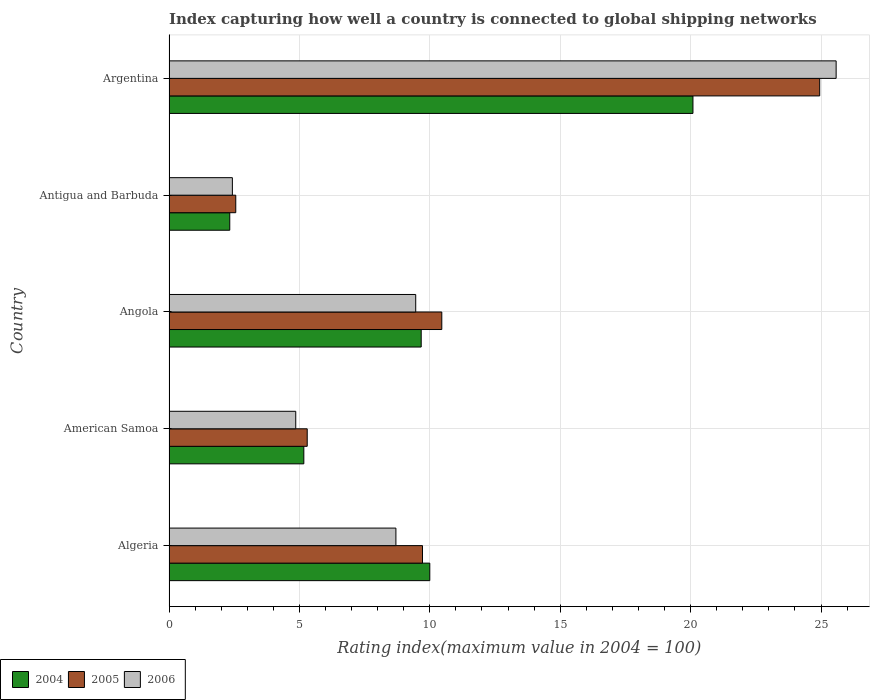How many groups of bars are there?
Provide a short and direct response. 5. How many bars are there on the 5th tick from the top?
Offer a very short reply. 3. How many bars are there on the 4th tick from the bottom?
Provide a short and direct response. 3. What is the label of the 2nd group of bars from the top?
Your answer should be compact. Antigua and Barbuda. What is the rating index in 2004 in Argentina?
Make the answer very short. 20.09. Across all countries, what is the maximum rating index in 2006?
Provide a short and direct response. 25.58. Across all countries, what is the minimum rating index in 2005?
Your answer should be very brief. 2.56. In which country was the rating index in 2005 minimum?
Your response must be concise. Antigua and Barbuda. What is the total rating index in 2006 in the graph?
Offer a terse response. 51.03. What is the difference between the rating index in 2005 in Algeria and that in Angola?
Provide a succinct answer. -0.74. What is the difference between the rating index in 2005 in Antigua and Barbuda and the rating index in 2006 in Algeria?
Offer a terse response. -6.14. What is the average rating index in 2004 per country?
Offer a very short reply. 9.45. What is the difference between the rating index in 2005 and rating index in 2004 in Antigua and Barbuda?
Make the answer very short. 0.23. What is the ratio of the rating index in 2004 in American Samoa to that in Argentina?
Keep it short and to the point. 0.26. Is the difference between the rating index in 2005 in American Samoa and Antigua and Barbuda greater than the difference between the rating index in 2004 in American Samoa and Antigua and Barbuda?
Give a very brief answer. No. What is the difference between the highest and the second highest rating index in 2006?
Give a very brief answer. 16.12. What is the difference between the highest and the lowest rating index in 2004?
Provide a short and direct response. 17.76. In how many countries, is the rating index in 2004 greater than the average rating index in 2004 taken over all countries?
Provide a short and direct response. 3. What does the 3rd bar from the top in American Samoa represents?
Your response must be concise. 2004. Are all the bars in the graph horizontal?
Give a very brief answer. Yes. How many countries are there in the graph?
Provide a short and direct response. 5. What is the difference between two consecutive major ticks on the X-axis?
Offer a very short reply. 5. Does the graph contain grids?
Your response must be concise. Yes. Where does the legend appear in the graph?
Provide a short and direct response. Bottom left. How many legend labels are there?
Give a very brief answer. 3. What is the title of the graph?
Your answer should be compact. Index capturing how well a country is connected to global shipping networks. What is the label or title of the X-axis?
Your answer should be compact. Rating index(maximum value in 2004 = 100). What is the label or title of the Y-axis?
Your answer should be very brief. Country. What is the Rating index(maximum value in 2004 = 100) of 2005 in Algeria?
Provide a short and direct response. 9.72. What is the Rating index(maximum value in 2004 = 100) in 2006 in Algeria?
Your answer should be compact. 8.7. What is the Rating index(maximum value in 2004 = 100) in 2004 in American Samoa?
Your answer should be very brief. 5.17. What is the Rating index(maximum value in 2004 = 100) of 2006 in American Samoa?
Keep it short and to the point. 4.86. What is the Rating index(maximum value in 2004 = 100) of 2004 in Angola?
Ensure brevity in your answer.  9.67. What is the Rating index(maximum value in 2004 = 100) of 2005 in Angola?
Your response must be concise. 10.46. What is the Rating index(maximum value in 2004 = 100) of 2006 in Angola?
Your response must be concise. 9.46. What is the Rating index(maximum value in 2004 = 100) of 2004 in Antigua and Barbuda?
Offer a terse response. 2.33. What is the Rating index(maximum value in 2004 = 100) of 2005 in Antigua and Barbuda?
Ensure brevity in your answer.  2.56. What is the Rating index(maximum value in 2004 = 100) of 2006 in Antigua and Barbuda?
Your response must be concise. 2.43. What is the Rating index(maximum value in 2004 = 100) in 2004 in Argentina?
Offer a very short reply. 20.09. What is the Rating index(maximum value in 2004 = 100) in 2005 in Argentina?
Give a very brief answer. 24.95. What is the Rating index(maximum value in 2004 = 100) of 2006 in Argentina?
Keep it short and to the point. 25.58. Across all countries, what is the maximum Rating index(maximum value in 2004 = 100) in 2004?
Offer a very short reply. 20.09. Across all countries, what is the maximum Rating index(maximum value in 2004 = 100) of 2005?
Provide a short and direct response. 24.95. Across all countries, what is the maximum Rating index(maximum value in 2004 = 100) of 2006?
Keep it short and to the point. 25.58. Across all countries, what is the minimum Rating index(maximum value in 2004 = 100) of 2004?
Your answer should be very brief. 2.33. Across all countries, what is the minimum Rating index(maximum value in 2004 = 100) in 2005?
Offer a terse response. 2.56. Across all countries, what is the minimum Rating index(maximum value in 2004 = 100) of 2006?
Your answer should be very brief. 2.43. What is the total Rating index(maximum value in 2004 = 100) in 2004 in the graph?
Your answer should be very brief. 47.26. What is the total Rating index(maximum value in 2004 = 100) in 2005 in the graph?
Offer a terse response. 52.99. What is the total Rating index(maximum value in 2004 = 100) in 2006 in the graph?
Offer a very short reply. 51.03. What is the difference between the Rating index(maximum value in 2004 = 100) in 2004 in Algeria and that in American Samoa?
Provide a succinct answer. 4.83. What is the difference between the Rating index(maximum value in 2004 = 100) in 2005 in Algeria and that in American Samoa?
Provide a succinct answer. 4.42. What is the difference between the Rating index(maximum value in 2004 = 100) of 2006 in Algeria and that in American Samoa?
Provide a short and direct response. 3.84. What is the difference between the Rating index(maximum value in 2004 = 100) of 2004 in Algeria and that in Angola?
Your answer should be very brief. 0.33. What is the difference between the Rating index(maximum value in 2004 = 100) in 2005 in Algeria and that in Angola?
Ensure brevity in your answer.  -0.74. What is the difference between the Rating index(maximum value in 2004 = 100) in 2006 in Algeria and that in Angola?
Keep it short and to the point. -0.76. What is the difference between the Rating index(maximum value in 2004 = 100) in 2004 in Algeria and that in Antigua and Barbuda?
Make the answer very short. 7.67. What is the difference between the Rating index(maximum value in 2004 = 100) of 2005 in Algeria and that in Antigua and Barbuda?
Make the answer very short. 7.16. What is the difference between the Rating index(maximum value in 2004 = 100) in 2006 in Algeria and that in Antigua and Barbuda?
Your response must be concise. 6.27. What is the difference between the Rating index(maximum value in 2004 = 100) in 2004 in Algeria and that in Argentina?
Give a very brief answer. -10.09. What is the difference between the Rating index(maximum value in 2004 = 100) of 2005 in Algeria and that in Argentina?
Make the answer very short. -15.23. What is the difference between the Rating index(maximum value in 2004 = 100) of 2006 in Algeria and that in Argentina?
Offer a very short reply. -16.88. What is the difference between the Rating index(maximum value in 2004 = 100) in 2004 in American Samoa and that in Angola?
Your answer should be very brief. -4.5. What is the difference between the Rating index(maximum value in 2004 = 100) in 2005 in American Samoa and that in Angola?
Your answer should be compact. -5.16. What is the difference between the Rating index(maximum value in 2004 = 100) in 2004 in American Samoa and that in Antigua and Barbuda?
Ensure brevity in your answer.  2.84. What is the difference between the Rating index(maximum value in 2004 = 100) of 2005 in American Samoa and that in Antigua and Barbuda?
Offer a very short reply. 2.74. What is the difference between the Rating index(maximum value in 2004 = 100) of 2006 in American Samoa and that in Antigua and Barbuda?
Ensure brevity in your answer.  2.43. What is the difference between the Rating index(maximum value in 2004 = 100) of 2004 in American Samoa and that in Argentina?
Make the answer very short. -14.92. What is the difference between the Rating index(maximum value in 2004 = 100) of 2005 in American Samoa and that in Argentina?
Give a very brief answer. -19.65. What is the difference between the Rating index(maximum value in 2004 = 100) in 2006 in American Samoa and that in Argentina?
Keep it short and to the point. -20.72. What is the difference between the Rating index(maximum value in 2004 = 100) in 2004 in Angola and that in Antigua and Barbuda?
Provide a succinct answer. 7.34. What is the difference between the Rating index(maximum value in 2004 = 100) in 2005 in Angola and that in Antigua and Barbuda?
Your response must be concise. 7.9. What is the difference between the Rating index(maximum value in 2004 = 100) in 2006 in Angola and that in Antigua and Barbuda?
Your answer should be compact. 7.03. What is the difference between the Rating index(maximum value in 2004 = 100) of 2004 in Angola and that in Argentina?
Your answer should be compact. -10.42. What is the difference between the Rating index(maximum value in 2004 = 100) in 2005 in Angola and that in Argentina?
Keep it short and to the point. -14.49. What is the difference between the Rating index(maximum value in 2004 = 100) in 2006 in Angola and that in Argentina?
Give a very brief answer. -16.12. What is the difference between the Rating index(maximum value in 2004 = 100) of 2004 in Antigua and Barbuda and that in Argentina?
Give a very brief answer. -17.76. What is the difference between the Rating index(maximum value in 2004 = 100) in 2005 in Antigua and Barbuda and that in Argentina?
Give a very brief answer. -22.39. What is the difference between the Rating index(maximum value in 2004 = 100) of 2006 in Antigua and Barbuda and that in Argentina?
Provide a succinct answer. -23.15. What is the difference between the Rating index(maximum value in 2004 = 100) of 2004 in Algeria and the Rating index(maximum value in 2004 = 100) of 2006 in American Samoa?
Make the answer very short. 5.14. What is the difference between the Rating index(maximum value in 2004 = 100) in 2005 in Algeria and the Rating index(maximum value in 2004 = 100) in 2006 in American Samoa?
Your answer should be compact. 4.86. What is the difference between the Rating index(maximum value in 2004 = 100) of 2004 in Algeria and the Rating index(maximum value in 2004 = 100) of 2005 in Angola?
Offer a very short reply. -0.46. What is the difference between the Rating index(maximum value in 2004 = 100) of 2004 in Algeria and the Rating index(maximum value in 2004 = 100) of 2006 in Angola?
Your response must be concise. 0.54. What is the difference between the Rating index(maximum value in 2004 = 100) of 2005 in Algeria and the Rating index(maximum value in 2004 = 100) of 2006 in Angola?
Your answer should be very brief. 0.26. What is the difference between the Rating index(maximum value in 2004 = 100) in 2004 in Algeria and the Rating index(maximum value in 2004 = 100) in 2005 in Antigua and Barbuda?
Provide a short and direct response. 7.44. What is the difference between the Rating index(maximum value in 2004 = 100) of 2004 in Algeria and the Rating index(maximum value in 2004 = 100) of 2006 in Antigua and Barbuda?
Keep it short and to the point. 7.57. What is the difference between the Rating index(maximum value in 2004 = 100) of 2005 in Algeria and the Rating index(maximum value in 2004 = 100) of 2006 in Antigua and Barbuda?
Ensure brevity in your answer.  7.29. What is the difference between the Rating index(maximum value in 2004 = 100) of 2004 in Algeria and the Rating index(maximum value in 2004 = 100) of 2005 in Argentina?
Ensure brevity in your answer.  -14.95. What is the difference between the Rating index(maximum value in 2004 = 100) in 2004 in Algeria and the Rating index(maximum value in 2004 = 100) in 2006 in Argentina?
Give a very brief answer. -15.58. What is the difference between the Rating index(maximum value in 2004 = 100) in 2005 in Algeria and the Rating index(maximum value in 2004 = 100) in 2006 in Argentina?
Keep it short and to the point. -15.86. What is the difference between the Rating index(maximum value in 2004 = 100) of 2004 in American Samoa and the Rating index(maximum value in 2004 = 100) of 2005 in Angola?
Ensure brevity in your answer.  -5.29. What is the difference between the Rating index(maximum value in 2004 = 100) in 2004 in American Samoa and the Rating index(maximum value in 2004 = 100) in 2006 in Angola?
Provide a succinct answer. -4.29. What is the difference between the Rating index(maximum value in 2004 = 100) of 2005 in American Samoa and the Rating index(maximum value in 2004 = 100) of 2006 in Angola?
Your response must be concise. -4.16. What is the difference between the Rating index(maximum value in 2004 = 100) of 2004 in American Samoa and the Rating index(maximum value in 2004 = 100) of 2005 in Antigua and Barbuda?
Ensure brevity in your answer.  2.61. What is the difference between the Rating index(maximum value in 2004 = 100) in 2004 in American Samoa and the Rating index(maximum value in 2004 = 100) in 2006 in Antigua and Barbuda?
Provide a succinct answer. 2.74. What is the difference between the Rating index(maximum value in 2004 = 100) in 2005 in American Samoa and the Rating index(maximum value in 2004 = 100) in 2006 in Antigua and Barbuda?
Provide a succinct answer. 2.87. What is the difference between the Rating index(maximum value in 2004 = 100) in 2004 in American Samoa and the Rating index(maximum value in 2004 = 100) in 2005 in Argentina?
Give a very brief answer. -19.78. What is the difference between the Rating index(maximum value in 2004 = 100) in 2004 in American Samoa and the Rating index(maximum value in 2004 = 100) in 2006 in Argentina?
Offer a terse response. -20.41. What is the difference between the Rating index(maximum value in 2004 = 100) of 2005 in American Samoa and the Rating index(maximum value in 2004 = 100) of 2006 in Argentina?
Your answer should be very brief. -20.28. What is the difference between the Rating index(maximum value in 2004 = 100) of 2004 in Angola and the Rating index(maximum value in 2004 = 100) of 2005 in Antigua and Barbuda?
Your answer should be very brief. 7.11. What is the difference between the Rating index(maximum value in 2004 = 100) of 2004 in Angola and the Rating index(maximum value in 2004 = 100) of 2006 in Antigua and Barbuda?
Your answer should be very brief. 7.24. What is the difference between the Rating index(maximum value in 2004 = 100) of 2005 in Angola and the Rating index(maximum value in 2004 = 100) of 2006 in Antigua and Barbuda?
Offer a terse response. 8.03. What is the difference between the Rating index(maximum value in 2004 = 100) in 2004 in Angola and the Rating index(maximum value in 2004 = 100) in 2005 in Argentina?
Your answer should be compact. -15.28. What is the difference between the Rating index(maximum value in 2004 = 100) of 2004 in Angola and the Rating index(maximum value in 2004 = 100) of 2006 in Argentina?
Your answer should be compact. -15.91. What is the difference between the Rating index(maximum value in 2004 = 100) of 2005 in Angola and the Rating index(maximum value in 2004 = 100) of 2006 in Argentina?
Your answer should be very brief. -15.12. What is the difference between the Rating index(maximum value in 2004 = 100) in 2004 in Antigua and Barbuda and the Rating index(maximum value in 2004 = 100) in 2005 in Argentina?
Give a very brief answer. -22.62. What is the difference between the Rating index(maximum value in 2004 = 100) of 2004 in Antigua and Barbuda and the Rating index(maximum value in 2004 = 100) of 2006 in Argentina?
Keep it short and to the point. -23.25. What is the difference between the Rating index(maximum value in 2004 = 100) of 2005 in Antigua and Barbuda and the Rating index(maximum value in 2004 = 100) of 2006 in Argentina?
Your response must be concise. -23.02. What is the average Rating index(maximum value in 2004 = 100) in 2004 per country?
Your answer should be very brief. 9.45. What is the average Rating index(maximum value in 2004 = 100) in 2005 per country?
Your answer should be very brief. 10.6. What is the average Rating index(maximum value in 2004 = 100) of 2006 per country?
Provide a succinct answer. 10.21. What is the difference between the Rating index(maximum value in 2004 = 100) of 2004 and Rating index(maximum value in 2004 = 100) of 2005 in Algeria?
Keep it short and to the point. 0.28. What is the difference between the Rating index(maximum value in 2004 = 100) of 2005 and Rating index(maximum value in 2004 = 100) of 2006 in Algeria?
Provide a short and direct response. 1.02. What is the difference between the Rating index(maximum value in 2004 = 100) of 2004 and Rating index(maximum value in 2004 = 100) of 2005 in American Samoa?
Make the answer very short. -0.13. What is the difference between the Rating index(maximum value in 2004 = 100) in 2004 and Rating index(maximum value in 2004 = 100) in 2006 in American Samoa?
Your answer should be compact. 0.31. What is the difference between the Rating index(maximum value in 2004 = 100) in 2005 and Rating index(maximum value in 2004 = 100) in 2006 in American Samoa?
Your answer should be very brief. 0.44. What is the difference between the Rating index(maximum value in 2004 = 100) of 2004 and Rating index(maximum value in 2004 = 100) of 2005 in Angola?
Your answer should be compact. -0.79. What is the difference between the Rating index(maximum value in 2004 = 100) in 2004 and Rating index(maximum value in 2004 = 100) in 2006 in Angola?
Your answer should be compact. 0.21. What is the difference between the Rating index(maximum value in 2004 = 100) of 2004 and Rating index(maximum value in 2004 = 100) of 2005 in Antigua and Barbuda?
Your response must be concise. -0.23. What is the difference between the Rating index(maximum value in 2004 = 100) of 2004 and Rating index(maximum value in 2004 = 100) of 2006 in Antigua and Barbuda?
Offer a very short reply. -0.1. What is the difference between the Rating index(maximum value in 2004 = 100) of 2005 and Rating index(maximum value in 2004 = 100) of 2006 in Antigua and Barbuda?
Offer a very short reply. 0.13. What is the difference between the Rating index(maximum value in 2004 = 100) of 2004 and Rating index(maximum value in 2004 = 100) of 2005 in Argentina?
Provide a short and direct response. -4.86. What is the difference between the Rating index(maximum value in 2004 = 100) of 2004 and Rating index(maximum value in 2004 = 100) of 2006 in Argentina?
Offer a terse response. -5.49. What is the difference between the Rating index(maximum value in 2004 = 100) in 2005 and Rating index(maximum value in 2004 = 100) in 2006 in Argentina?
Provide a succinct answer. -0.63. What is the ratio of the Rating index(maximum value in 2004 = 100) in 2004 in Algeria to that in American Samoa?
Give a very brief answer. 1.93. What is the ratio of the Rating index(maximum value in 2004 = 100) of 2005 in Algeria to that in American Samoa?
Keep it short and to the point. 1.83. What is the ratio of the Rating index(maximum value in 2004 = 100) in 2006 in Algeria to that in American Samoa?
Your response must be concise. 1.79. What is the ratio of the Rating index(maximum value in 2004 = 100) in 2004 in Algeria to that in Angola?
Give a very brief answer. 1.03. What is the ratio of the Rating index(maximum value in 2004 = 100) in 2005 in Algeria to that in Angola?
Offer a terse response. 0.93. What is the ratio of the Rating index(maximum value in 2004 = 100) of 2006 in Algeria to that in Angola?
Provide a short and direct response. 0.92. What is the ratio of the Rating index(maximum value in 2004 = 100) of 2004 in Algeria to that in Antigua and Barbuda?
Give a very brief answer. 4.29. What is the ratio of the Rating index(maximum value in 2004 = 100) of 2005 in Algeria to that in Antigua and Barbuda?
Offer a very short reply. 3.8. What is the ratio of the Rating index(maximum value in 2004 = 100) in 2006 in Algeria to that in Antigua and Barbuda?
Keep it short and to the point. 3.58. What is the ratio of the Rating index(maximum value in 2004 = 100) of 2004 in Algeria to that in Argentina?
Keep it short and to the point. 0.5. What is the ratio of the Rating index(maximum value in 2004 = 100) of 2005 in Algeria to that in Argentina?
Offer a very short reply. 0.39. What is the ratio of the Rating index(maximum value in 2004 = 100) in 2006 in Algeria to that in Argentina?
Provide a short and direct response. 0.34. What is the ratio of the Rating index(maximum value in 2004 = 100) in 2004 in American Samoa to that in Angola?
Provide a short and direct response. 0.53. What is the ratio of the Rating index(maximum value in 2004 = 100) in 2005 in American Samoa to that in Angola?
Make the answer very short. 0.51. What is the ratio of the Rating index(maximum value in 2004 = 100) in 2006 in American Samoa to that in Angola?
Your response must be concise. 0.51. What is the ratio of the Rating index(maximum value in 2004 = 100) of 2004 in American Samoa to that in Antigua and Barbuda?
Your answer should be compact. 2.22. What is the ratio of the Rating index(maximum value in 2004 = 100) of 2005 in American Samoa to that in Antigua and Barbuda?
Your response must be concise. 2.07. What is the ratio of the Rating index(maximum value in 2004 = 100) in 2006 in American Samoa to that in Antigua and Barbuda?
Provide a short and direct response. 2. What is the ratio of the Rating index(maximum value in 2004 = 100) of 2004 in American Samoa to that in Argentina?
Offer a terse response. 0.26. What is the ratio of the Rating index(maximum value in 2004 = 100) of 2005 in American Samoa to that in Argentina?
Your answer should be very brief. 0.21. What is the ratio of the Rating index(maximum value in 2004 = 100) of 2006 in American Samoa to that in Argentina?
Give a very brief answer. 0.19. What is the ratio of the Rating index(maximum value in 2004 = 100) in 2004 in Angola to that in Antigua and Barbuda?
Your answer should be very brief. 4.15. What is the ratio of the Rating index(maximum value in 2004 = 100) in 2005 in Angola to that in Antigua and Barbuda?
Give a very brief answer. 4.09. What is the ratio of the Rating index(maximum value in 2004 = 100) of 2006 in Angola to that in Antigua and Barbuda?
Provide a short and direct response. 3.89. What is the ratio of the Rating index(maximum value in 2004 = 100) of 2004 in Angola to that in Argentina?
Provide a succinct answer. 0.48. What is the ratio of the Rating index(maximum value in 2004 = 100) of 2005 in Angola to that in Argentina?
Provide a succinct answer. 0.42. What is the ratio of the Rating index(maximum value in 2004 = 100) of 2006 in Angola to that in Argentina?
Offer a terse response. 0.37. What is the ratio of the Rating index(maximum value in 2004 = 100) of 2004 in Antigua and Barbuda to that in Argentina?
Your response must be concise. 0.12. What is the ratio of the Rating index(maximum value in 2004 = 100) of 2005 in Antigua and Barbuda to that in Argentina?
Offer a terse response. 0.1. What is the ratio of the Rating index(maximum value in 2004 = 100) of 2006 in Antigua and Barbuda to that in Argentina?
Ensure brevity in your answer.  0.1. What is the difference between the highest and the second highest Rating index(maximum value in 2004 = 100) in 2004?
Provide a succinct answer. 10.09. What is the difference between the highest and the second highest Rating index(maximum value in 2004 = 100) of 2005?
Give a very brief answer. 14.49. What is the difference between the highest and the second highest Rating index(maximum value in 2004 = 100) in 2006?
Offer a terse response. 16.12. What is the difference between the highest and the lowest Rating index(maximum value in 2004 = 100) of 2004?
Offer a very short reply. 17.76. What is the difference between the highest and the lowest Rating index(maximum value in 2004 = 100) in 2005?
Provide a succinct answer. 22.39. What is the difference between the highest and the lowest Rating index(maximum value in 2004 = 100) in 2006?
Ensure brevity in your answer.  23.15. 